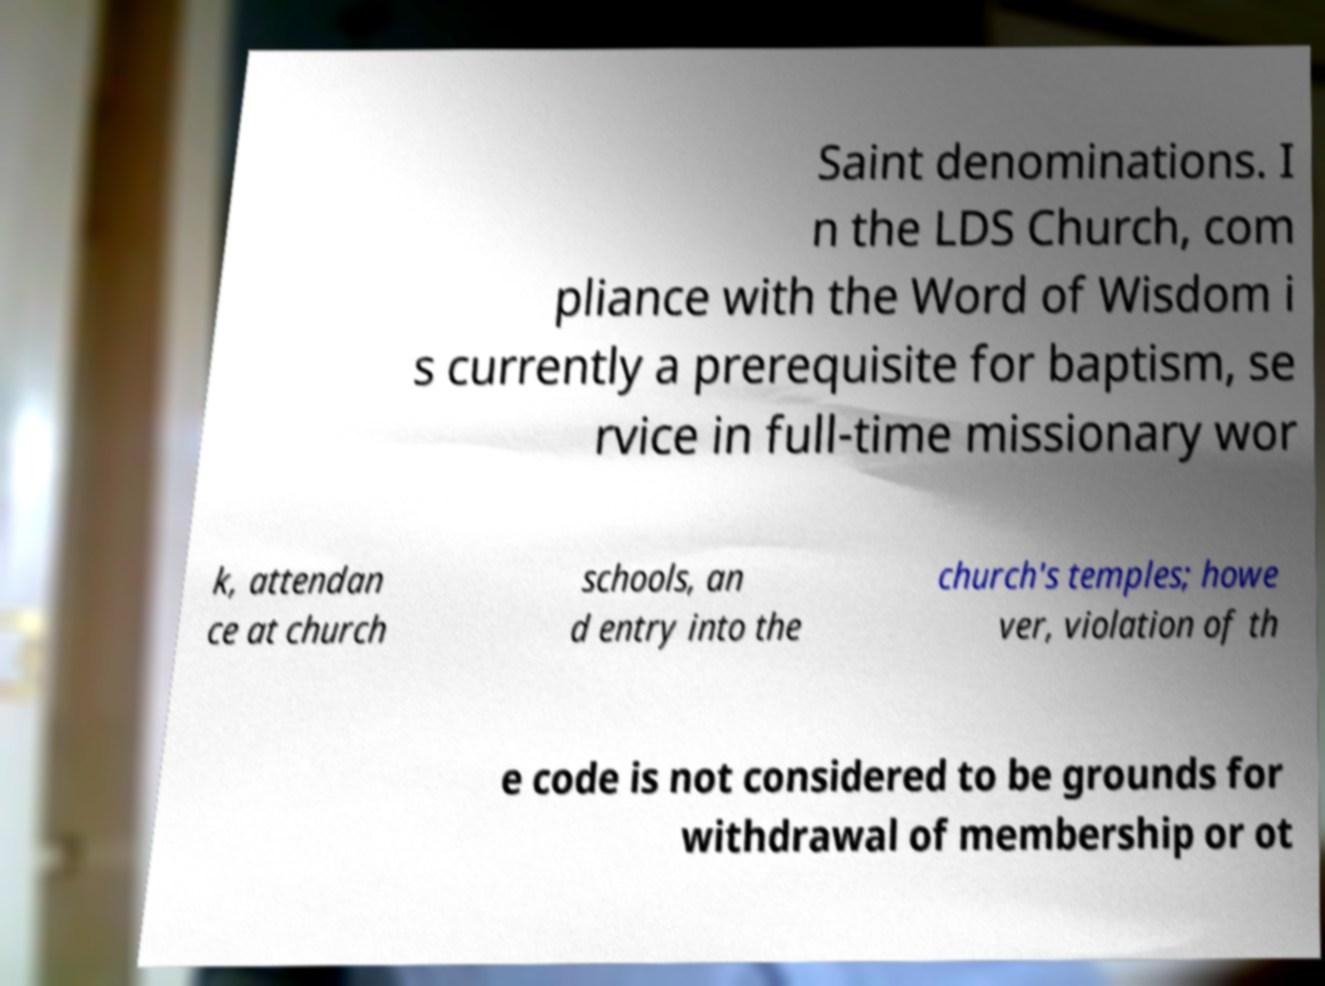What messages or text are displayed in this image? I need them in a readable, typed format. Saint denominations. I n the LDS Church, com pliance with the Word of Wisdom i s currently a prerequisite for baptism, se rvice in full-time missionary wor k, attendan ce at church schools, an d entry into the church's temples; howe ver, violation of th e code is not considered to be grounds for withdrawal of membership or ot 